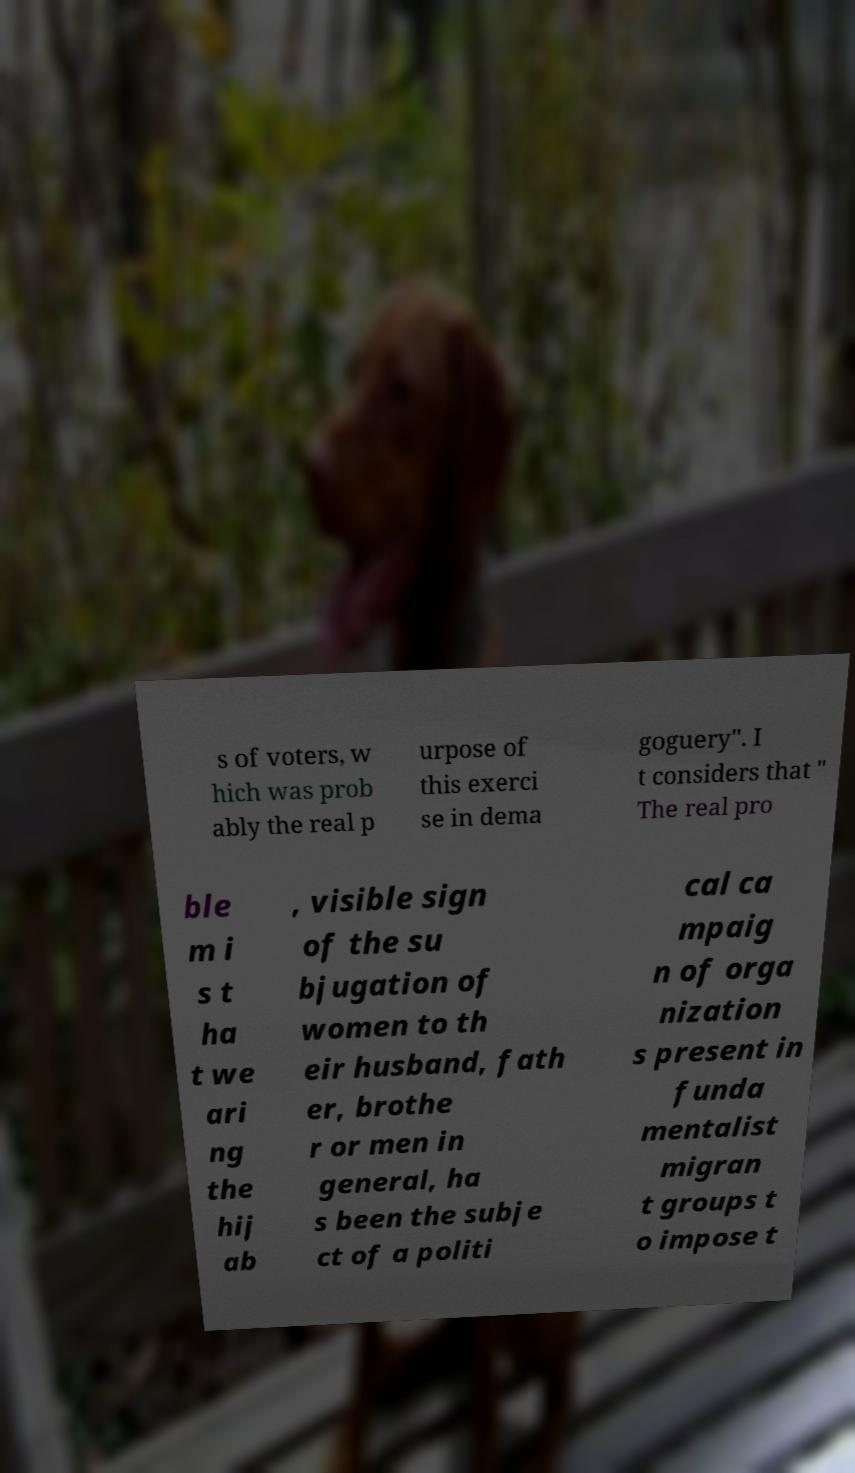I need the written content from this picture converted into text. Can you do that? s of voters, w hich was prob ably the real p urpose of this exerci se in dema goguery". I t considers that " The real pro ble m i s t ha t we ari ng the hij ab , visible sign of the su bjugation of women to th eir husband, fath er, brothe r or men in general, ha s been the subje ct of a politi cal ca mpaig n of orga nization s present in funda mentalist migran t groups t o impose t 